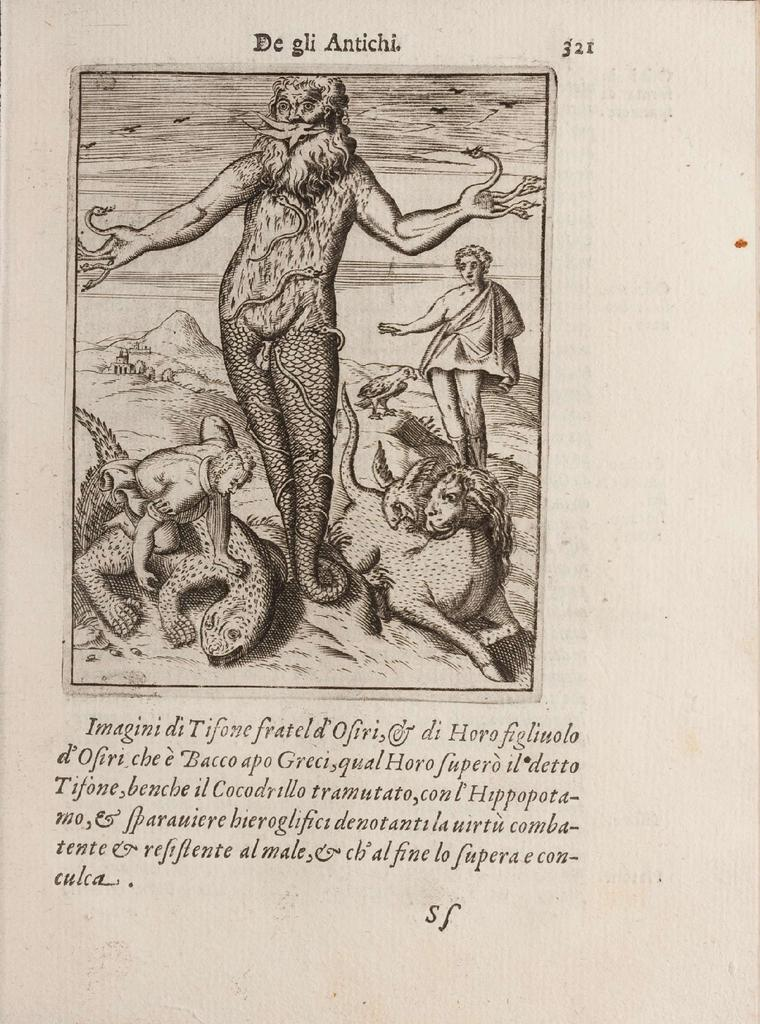What is present in the image that is made of paper? There is a paper in the image. What can be seen in the center of the image? There are people and animals in the center of the image. What type of natural feature is visible in the background of the image? There are hills in the background of the image. Where is the text located in the image? The text is at the top and bottom of the image. What type of juice is being served to the rabbit in the image? There is no rabbit or juice present in the image. How is the coal being used by the people in the image? There is no coal present in the image. 